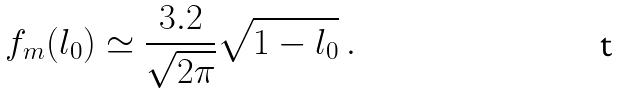<formula> <loc_0><loc_0><loc_500><loc_500>f _ { m } ( l _ { 0 } ) \simeq \frac { 3 . 2 } { \sqrt { 2 \pi } } \sqrt { 1 - l _ { 0 } } \ .</formula> 